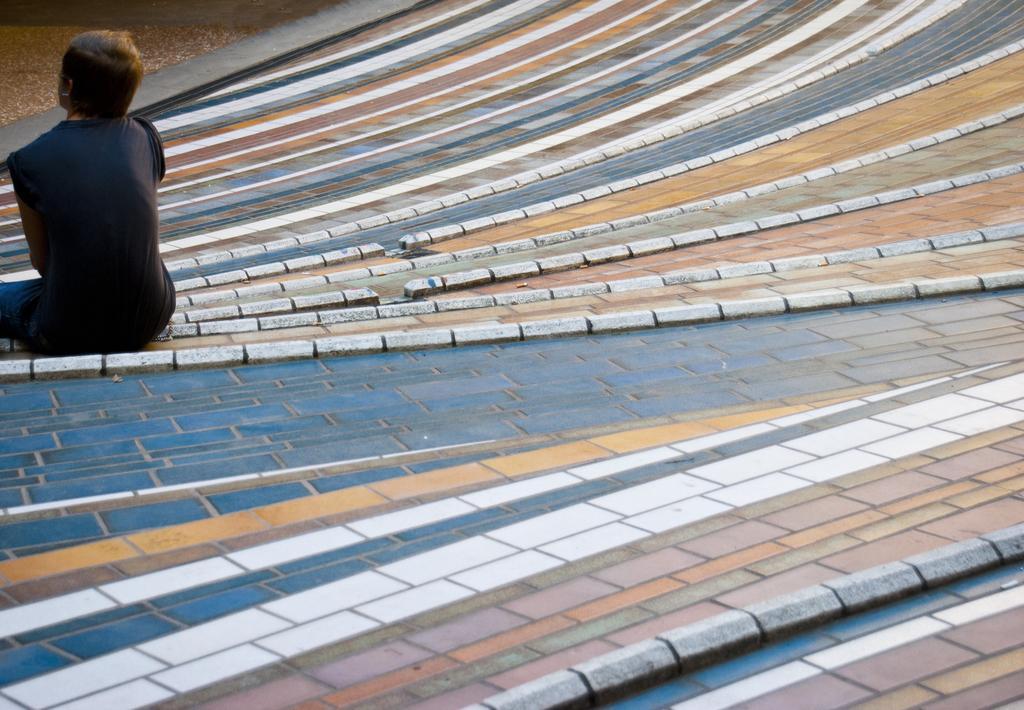Please provide a concise description of this image. In this image I can see a person sitting on the colorful floor. He is wearing black top. 